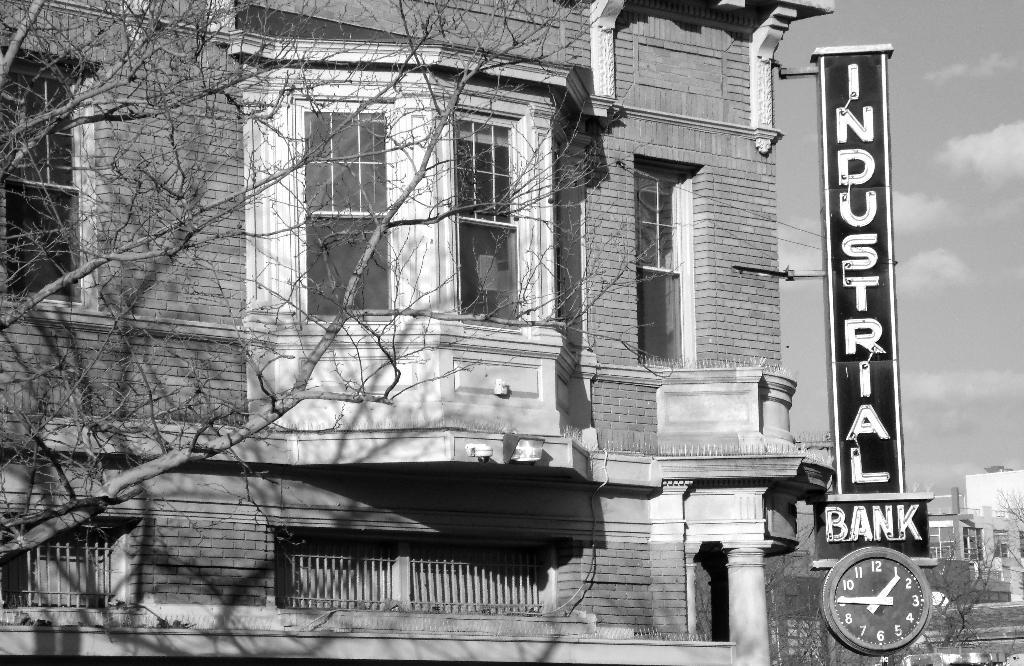<image>
Create a compact narrative representing the image presented. An old building with a large Industrial Bank Sign. 